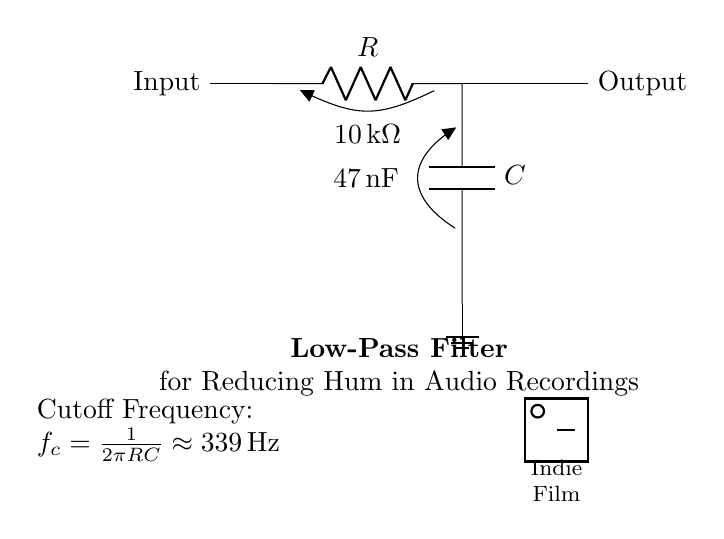What type of filter is this? The circuit is a low-pass filter, designed to allow low-frequency signals to pass while attenuating higher frequencies. This is indicated by the components used (a resistor and a capacitor) and the label in the diagram.
Answer: Low-pass filter What is the value of the resistor? The resistor's value is explicitly shown in the circuit diagram as ten thousand ohms, or ten kilo-ohms.
Answer: Ten thousand ohms What is the capacitance value? The circuit diagram states that the capacitor has a value of forty-seven nanofarads. This is specified next to the capacitor symbol.
Answer: Forty-seven nanofarads What is the cutoff frequency of this filter? The cutoff frequency is calculated using the formula presented in the diagram \( f_c = \frac{1}{2\pi RC} \). Substituting the given values results in approximately three hundred thirty-nine hertz.
Answer: Three hundred thirty-nine hertz How are the components connected in this circuit? The components are connected in a series configuration where the input feeds through the resistor to the capacitor, which is then grounded. The output is taken from the junction between the resistor and capacitor.
Answer: In series What is the primary purpose of this circuit? The main purpose of this low-pass filter circuit is to reduce hum in audio recordings by filtering out high-frequency noise while allowing low-frequency audio signals to pass through.
Answer: To reduce hum in audio recordings 